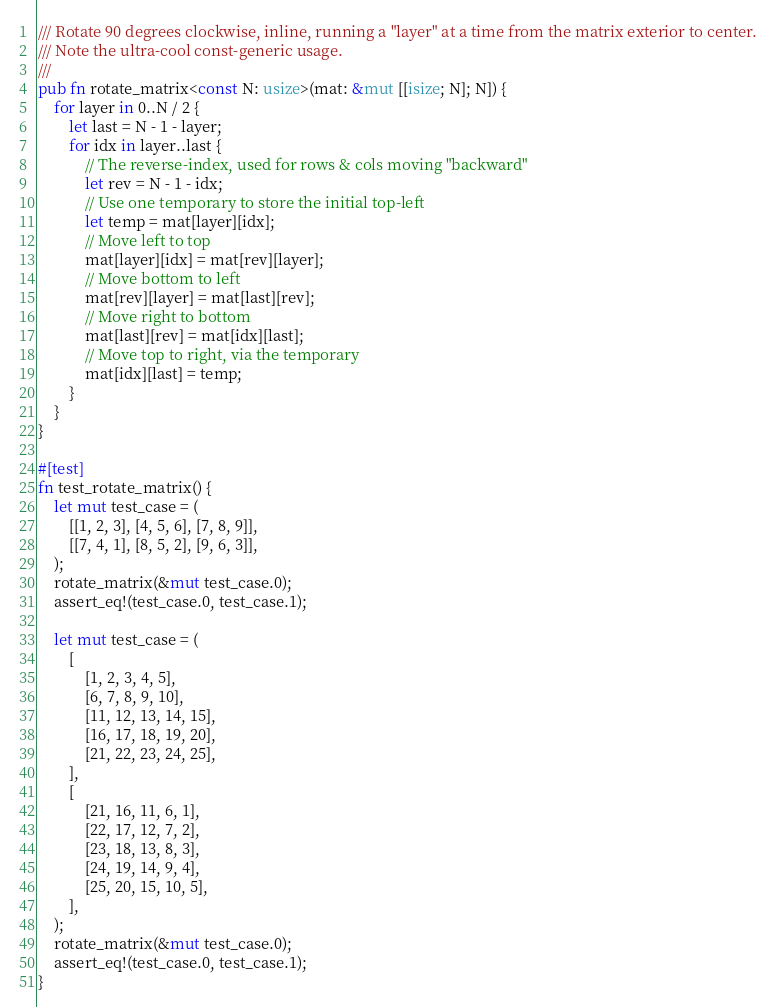<code> <loc_0><loc_0><loc_500><loc_500><_Rust_>/// Rotate 90 degrees clockwise, inline, running a "layer" at a time from the matrix exterior to center.
/// Note the ultra-cool const-generic usage.
///
pub fn rotate_matrix<const N: usize>(mat: &mut [[isize; N]; N]) {
    for layer in 0..N / 2 {
        let last = N - 1 - layer;
        for idx in layer..last {
            // The reverse-index, used for rows & cols moving "backward"
            let rev = N - 1 - idx;
            // Use one temporary to store the initial top-left
            let temp = mat[layer][idx];
            // Move left to top
            mat[layer][idx] = mat[rev][layer];
            // Move bottom to left
            mat[rev][layer] = mat[last][rev];
            // Move right to bottom
            mat[last][rev] = mat[idx][last];
            // Move top to right, via the temporary
            mat[idx][last] = temp;
        }
    }
}

#[test]
fn test_rotate_matrix() {
    let mut test_case = (
        [[1, 2, 3], [4, 5, 6], [7, 8, 9]],
        [[7, 4, 1], [8, 5, 2], [9, 6, 3]],
    );
    rotate_matrix(&mut test_case.0);
    assert_eq!(test_case.0, test_case.1);

    let mut test_case = (
        [
            [1, 2, 3, 4, 5],
            [6, 7, 8, 9, 10],
            [11, 12, 13, 14, 15],
            [16, 17, 18, 19, 20],
            [21, 22, 23, 24, 25],
        ],
        [
            [21, 16, 11, 6, 1],
            [22, 17, 12, 7, 2],
            [23, 18, 13, 8, 3],
            [24, 19, 14, 9, 4],
            [25, 20, 15, 10, 5],
        ],
    );
    rotate_matrix(&mut test_case.0);
    assert_eq!(test_case.0, test_case.1);
}
</code> 